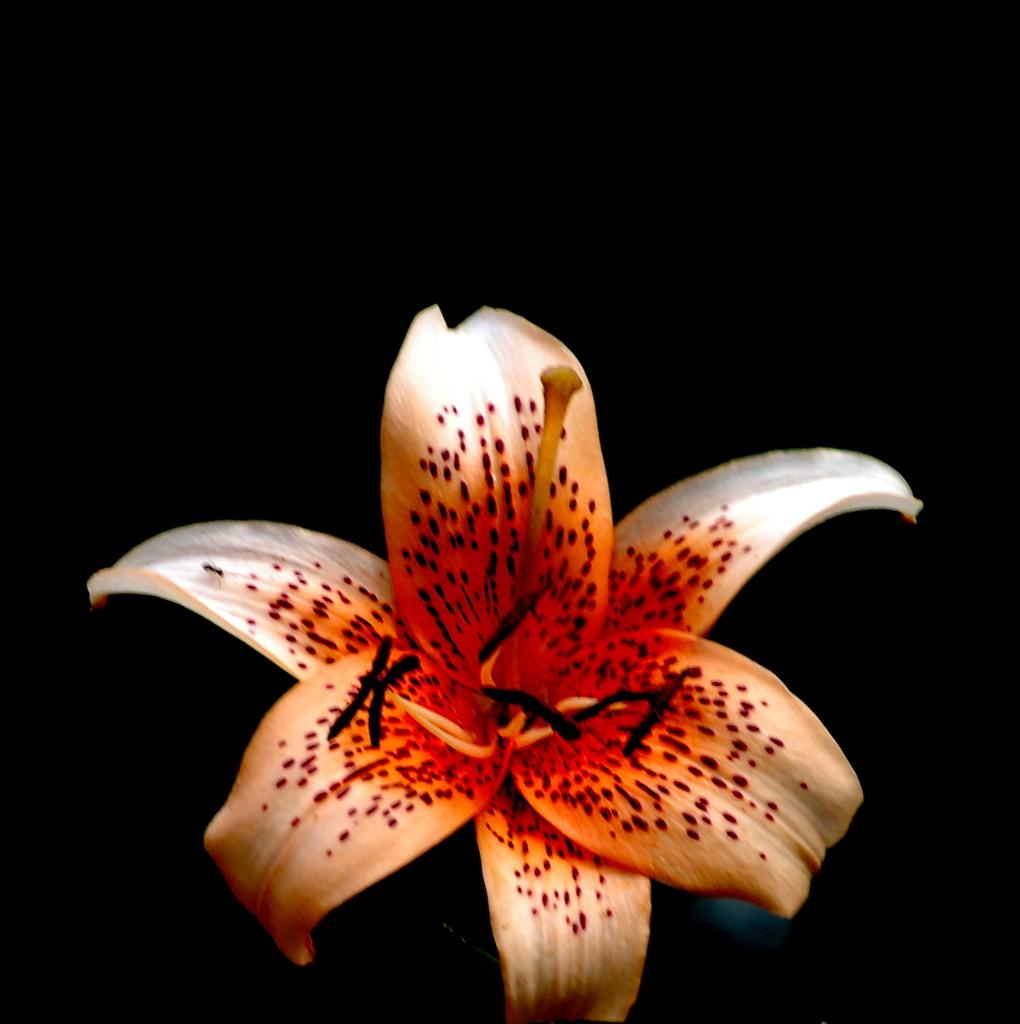What type of flower is in the image? There is a lily flower in the image. How would you describe the background of the image? The background of the image is dark. Can you see any spies or boats in the image? There are no spies or boats present in the image; it features a lily flower with a dark background. Are there any icicles visible in the image? There are no icicles present in the image; it features a lily flower with a dark background. 